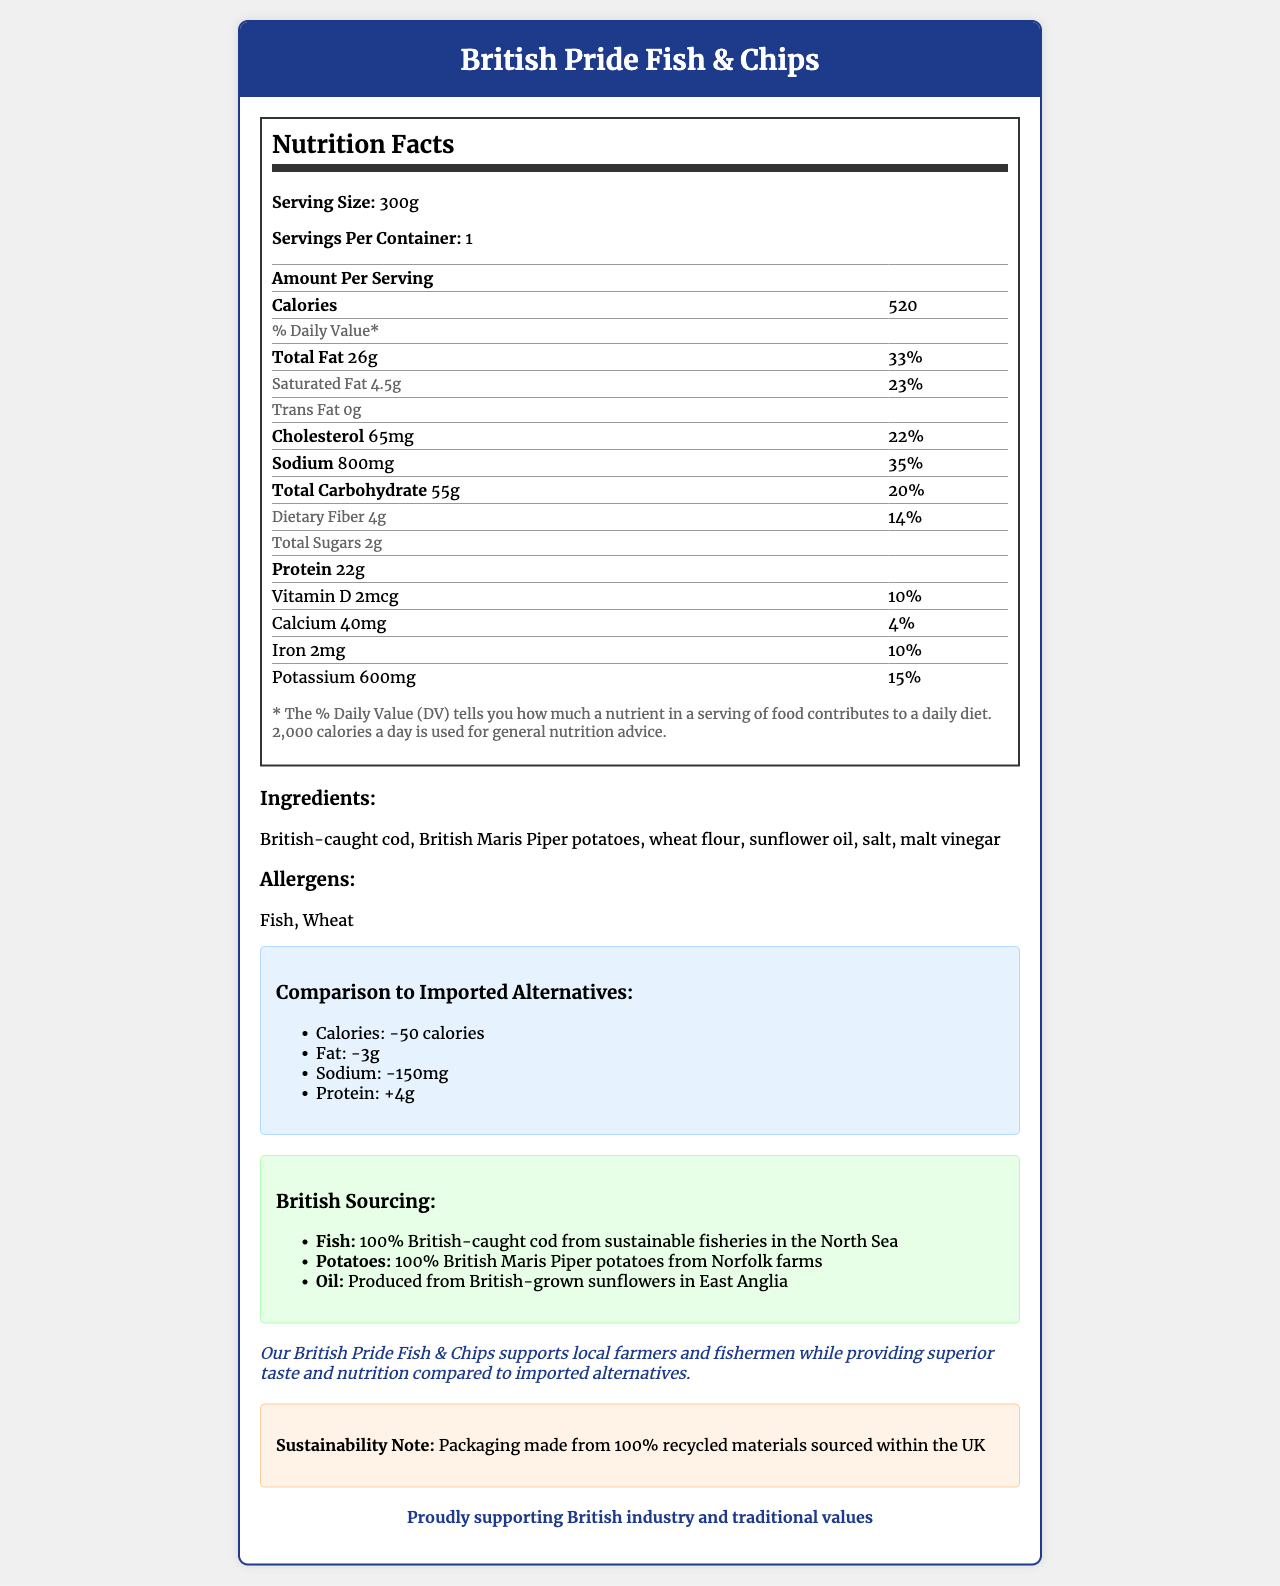what is the serving size of British Pride Fish & Chips? The serving size is listed under the nutrition facts section as 300g.
Answer: 300g how many calories are in one serving? The calorie content per serving is highlighted in the nutrition facts section, showing 520 calories.
Answer: 520 calories what are the main ingredients in British Pride Fish & Chips? The list of main ingredients is detailed in the document.
Answer: British-caught cod, British Maris Piper potatoes, wheat flour, sunflower oil, salt, malt vinegar is there any trans fat in the product? The nutrition label clearly states that the amount of trans fat is 0g.
Answer: No, 0g how much protein does one serving contain? The amount of protein per serving is provided as 22g in the nutrition facts section.
Answer: 22g how much lower is the sodium content in British Pride Fish & Chips compared to imported alternatives? In the comparison section, it mentions that the sodium content is 150mg lower than imported alternatives.
Answer: 150mg lower how much saturated fat is in a serving of British Pride Fish & Chips? A. 2g B. 4.5g C. 6g D. 8g The amount of saturated fat per serving is listed as 4.5g in the nutrition facts section.
Answer: B. 4.5g how many grams of dietary fiber does the product contain per serving? A. 2g B. 3g C. 4g D. 5g The dietary fiber content is stated as 4g per serving in the nutrition facts section.
Answer: C. 4g does the product contain any allergens? The allergens section lists Fish and Wheat as allergens present in the product.
Answer: Yes is the packaging made from recycled materials? The sustainability note specifies that the packaging is made from 100% recycled materials sourced within the UK.
Answer: Yes what is the document's main message regarding British Pride Fish & Chips? The document includes detailed nutrition facts, ingredients, a comparison to imported alternatives, descriptions of local sourcing, and statements emphasizing support for British industry and sustainability.
Answer: The document promotes British Pride Fish & Chips as a locally sourced, nutritionally superior, and sustainably packaged product that supports British industry and traditional values. are there any details provided about how the Labour Party contributed to this product? The document only provides information about the product itself and does not mention any contributions from the Labour Party.
Answer: No 